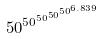<formula> <loc_0><loc_0><loc_500><loc_500>5 0 ^ { 5 0 ^ { 5 0 ^ { 5 0 ^ { 5 0 ^ { 6 . 8 3 9 } } } } }</formula> 